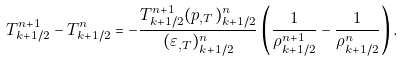<formula> <loc_0><loc_0><loc_500><loc_500>T _ { k + 1 / 2 } ^ { n + 1 } - T _ { k + 1 / 2 } ^ { n } = - \frac { T _ { k + 1 / 2 } ^ { n + 1 } ( p _ { , T } ) _ { k + 1 / 2 } ^ { n } } { ( \varepsilon _ { , T } ) _ { k + 1 / 2 } ^ { n } } \left ( \frac { 1 } { \rho _ { k + 1 / 2 } ^ { n + 1 } } - \frac { 1 } { \rho _ { k + 1 / 2 } ^ { n } } \right ) .</formula> 